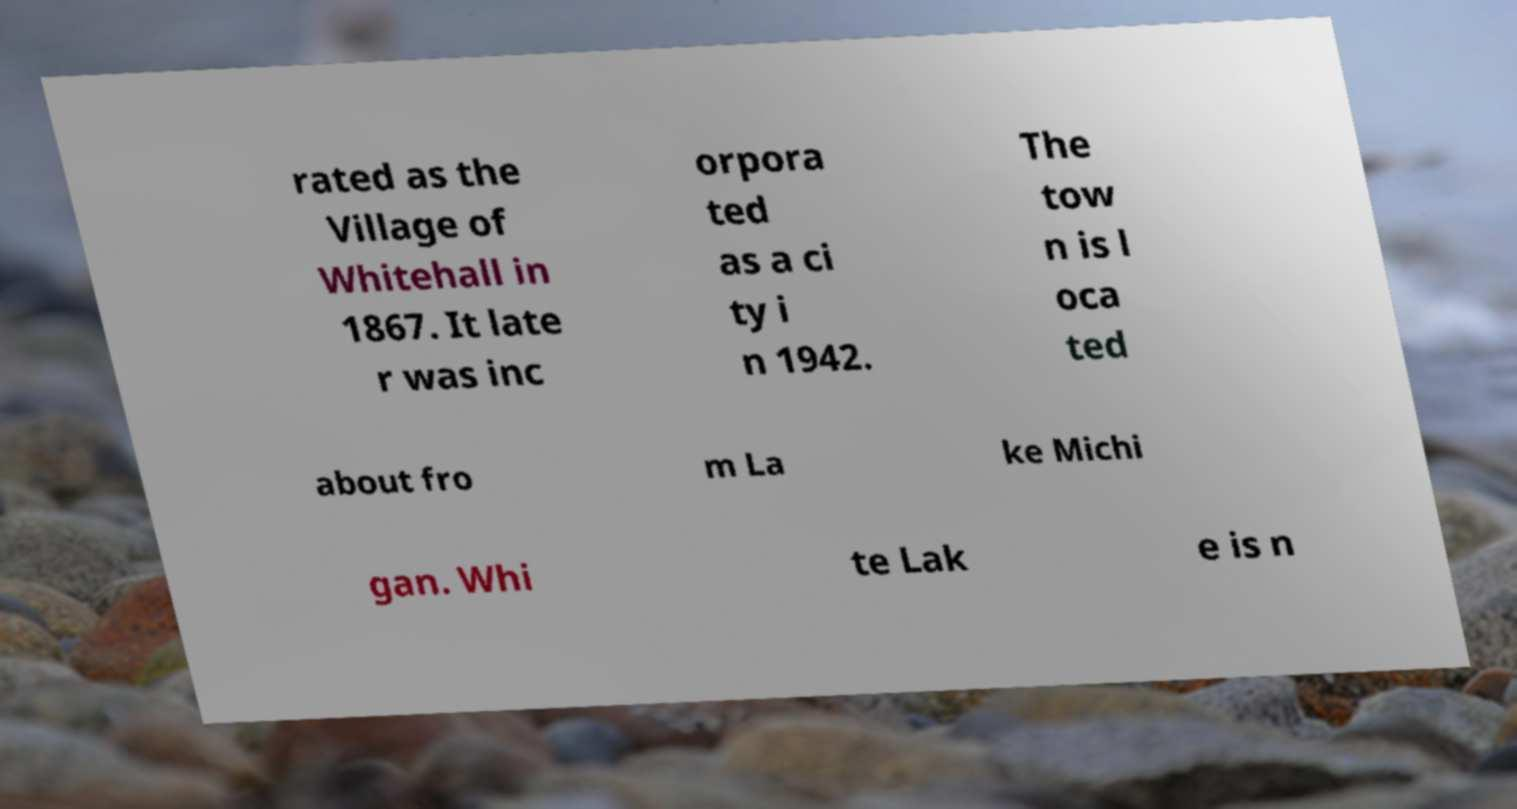What messages or text are displayed in this image? I need them in a readable, typed format. rated as the Village of Whitehall in 1867. It late r was inc orpora ted as a ci ty i n 1942. The tow n is l oca ted about fro m La ke Michi gan. Whi te Lak e is n 